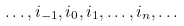<formula> <loc_0><loc_0><loc_500><loc_500>\dots , i _ { - 1 } , i _ { 0 } , i _ { 1 } , \dots , i _ { n } , \dots</formula> 